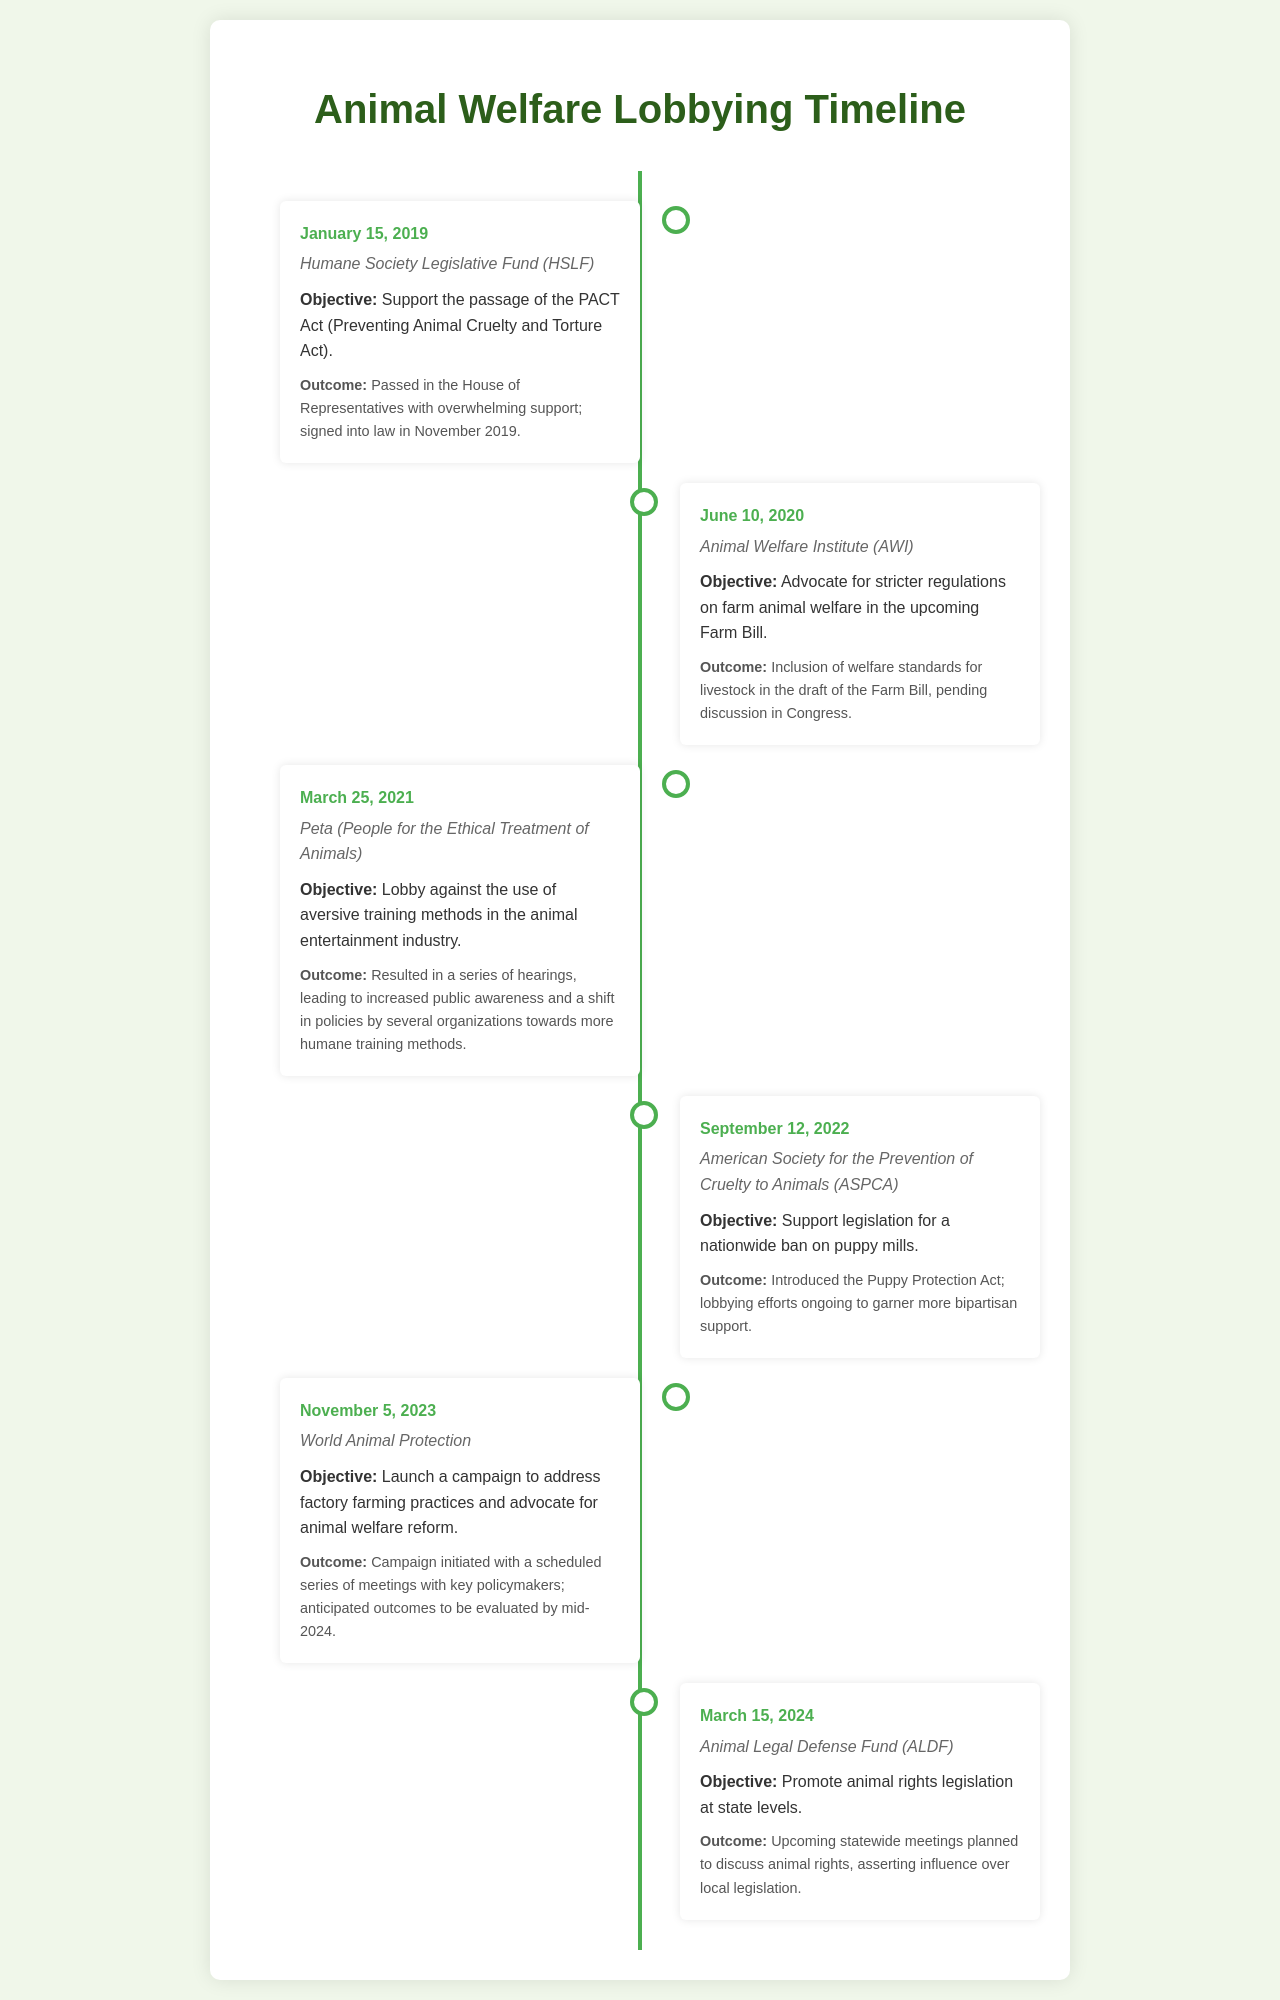What organization supported the passage of the PACT Act? The document states that the Humane Society Legislative Fund (HSLF) supported the passage of the PACT Act.
Answer: Humane Society Legislative Fund (HSLF) What was the outcome of the lobbying on March 25, 2021? The document indicates that this lobbying resulted in hearings, increased public awareness, and policy shifts toward humane training methods.
Answer: Increased public awareness and policy shifts What legislation was introduced on September 12, 2022? According to the document, the Puppy Protection Act was introduced on this date.
Answer: Puppy Protection Act When did the Animal Legal Defense Fund plan statewide meetings? The document notes that the statewide meetings are scheduled for March 15, 2024.
Answer: March 15, 2024 What was the objective of the World Animal Protection's campaign launched on November 5, 2023? The objective was to address factory farming practices and advocate for animal welfare reform.
Answer: Address factory farming practices and advocate for animal welfare reform Which organization's objective was to advocate for stricter regulations in the Farm Bill? The document informs that the Animal Welfare Institute (AWI) aimed to advocate for these regulations.
Answer: Animal Welfare Institute (AWI) How many entries are there in the timeline? The document outlines that there are a total of six entries listed in the timeline.
Answer: Six entries What type of lobbying effort occurred on June 10, 2020? The document describes this as an advocacy effort for stricter regulations on farm animal welfare.
Answer: Advocacy for stricter regulations on farm animal welfare What significant event occurred in November 2019 related to the PACT Act? The document states that the PACT Act was signed into law in November 2019.
Answer: Signed into law 